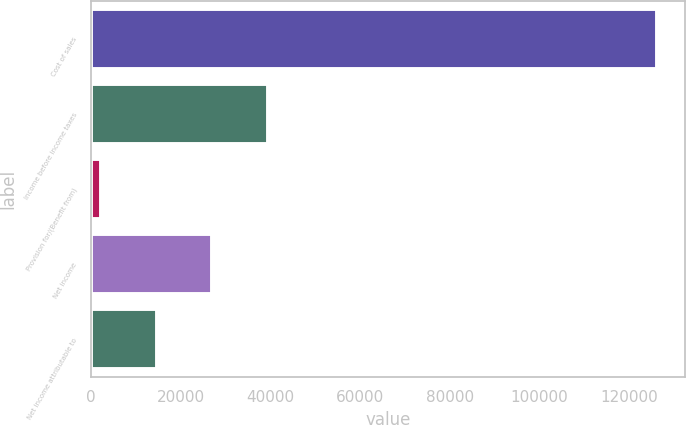<chart> <loc_0><loc_0><loc_500><loc_500><bar_chart><fcel>Cost of sales<fcel>Income before income taxes<fcel>Provision for/(Benefit from)<fcel>Net income<fcel>Net income attributable to<nl><fcel>126195<fcel>39387.3<fcel>2184<fcel>26986.2<fcel>14585.1<nl></chart> 